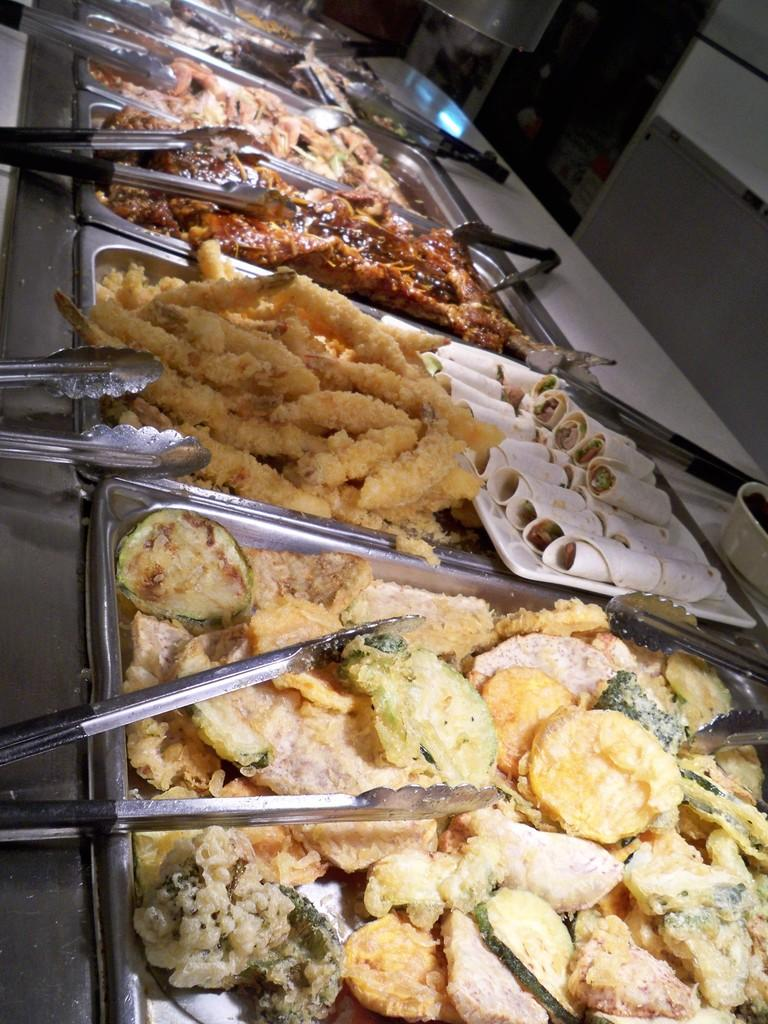What is in the bowls that are visible in the image? There is food in the bowls in the image. What utensil can be seen in the image? There are tongs visible in the image. What is the growth rate of the pan in the image? There is no pan present in the image, so it is not possible to determine its growth rate. 